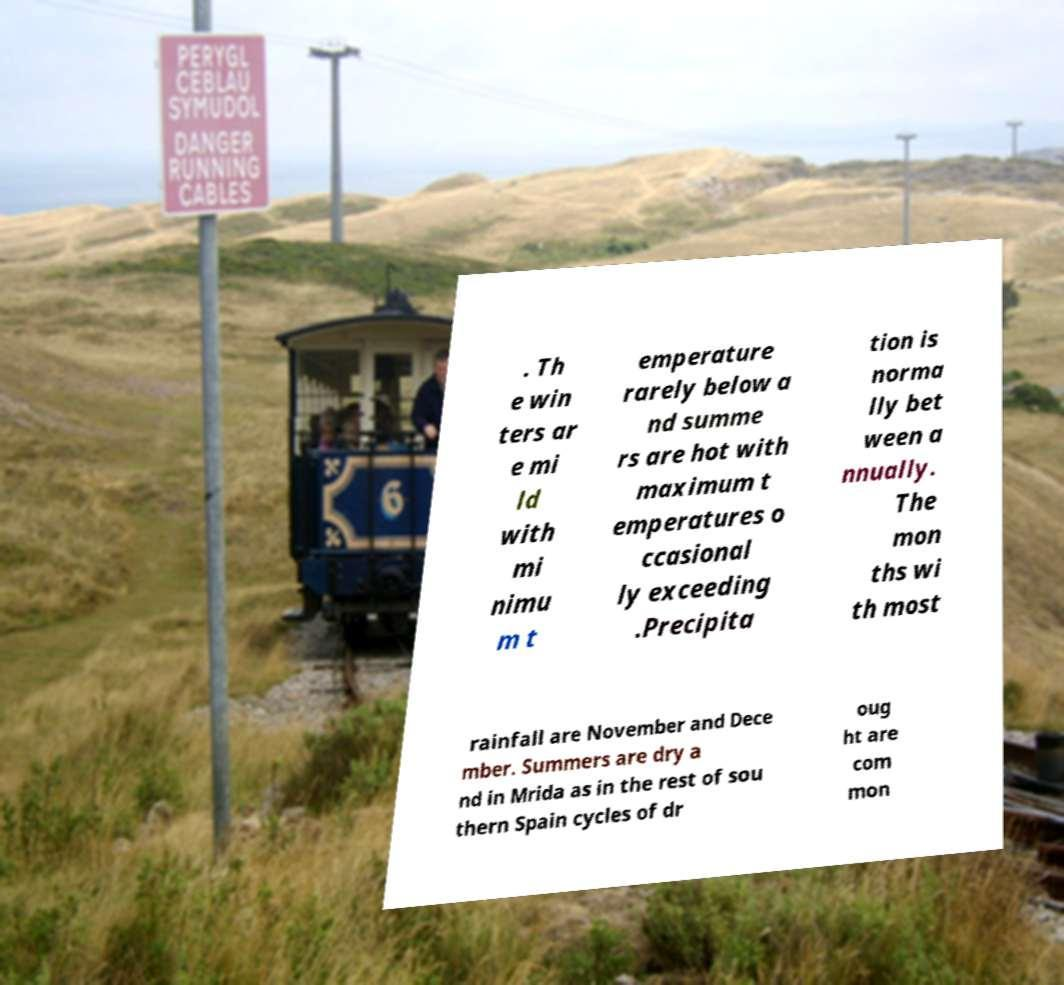Could you extract and type out the text from this image? . Th e win ters ar e mi ld with mi nimu m t emperature rarely below a nd summe rs are hot with maximum t emperatures o ccasional ly exceeding .Precipita tion is norma lly bet ween a nnually. The mon ths wi th most rainfall are November and Dece mber. Summers are dry a nd in Mrida as in the rest of sou thern Spain cycles of dr oug ht are com mon 